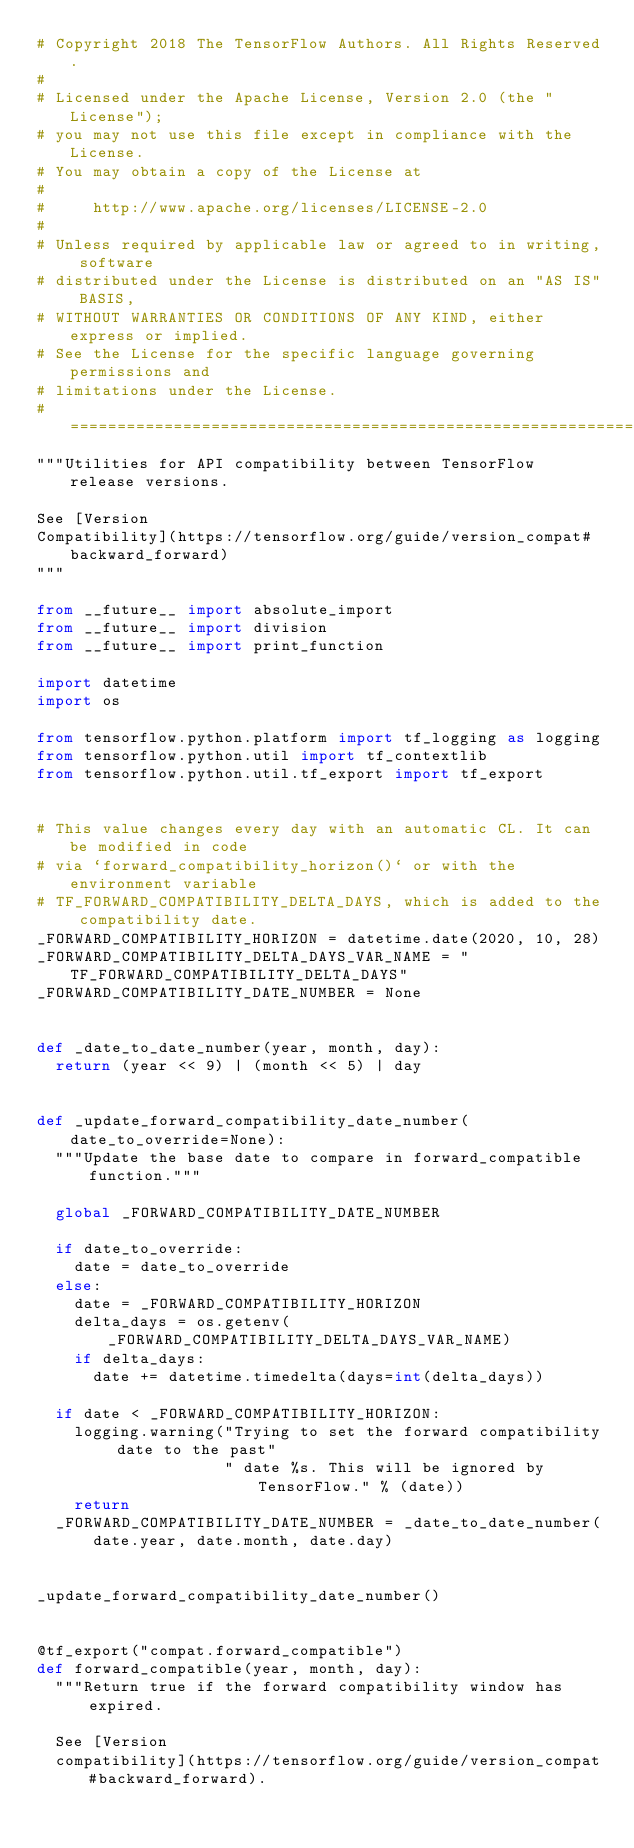<code> <loc_0><loc_0><loc_500><loc_500><_Python_># Copyright 2018 The TensorFlow Authors. All Rights Reserved.
#
# Licensed under the Apache License, Version 2.0 (the "License");
# you may not use this file except in compliance with the License.
# You may obtain a copy of the License at
#
#     http://www.apache.org/licenses/LICENSE-2.0
#
# Unless required by applicable law or agreed to in writing, software
# distributed under the License is distributed on an "AS IS" BASIS,
# WITHOUT WARRANTIES OR CONDITIONS OF ANY KIND, either express or implied.
# See the License for the specific language governing permissions and
# limitations under the License.
# ==============================================================================
"""Utilities for API compatibility between TensorFlow release versions.

See [Version
Compatibility](https://tensorflow.org/guide/version_compat#backward_forward)
"""

from __future__ import absolute_import
from __future__ import division
from __future__ import print_function

import datetime
import os

from tensorflow.python.platform import tf_logging as logging
from tensorflow.python.util import tf_contextlib
from tensorflow.python.util.tf_export import tf_export


# This value changes every day with an automatic CL. It can be modified in code
# via `forward_compatibility_horizon()` or with the environment variable
# TF_FORWARD_COMPATIBILITY_DELTA_DAYS, which is added to the compatibility date.
_FORWARD_COMPATIBILITY_HORIZON = datetime.date(2020, 10, 28)
_FORWARD_COMPATIBILITY_DELTA_DAYS_VAR_NAME = "TF_FORWARD_COMPATIBILITY_DELTA_DAYS"
_FORWARD_COMPATIBILITY_DATE_NUMBER = None


def _date_to_date_number(year, month, day):
  return (year << 9) | (month << 5) | day


def _update_forward_compatibility_date_number(date_to_override=None):
  """Update the base date to compare in forward_compatible function."""

  global _FORWARD_COMPATIBILITY_DATE_NUMBER

  if date_to_override:
    date = date_to_override
  else:
    date = _FORWARD_COMPATIBILITY_HORIZON
    delta_days = os.getenv(_FORWARD_COMPATIBILITY_DELTA_DAYS_VAR_NAME)
    if delta_days:
      date += datetime.timedelta(days=int(delta_days))

  if date < _FORWARD_COMPATIBILITY_HORIZON:
    logging.warning("Trying to set the forward compatibility date to the past"
                    " date %s. This will be ignored by TensorFlow." % (date))
    return
  _FORWARD_COMPATIBILITY_DATE_NUMBER = _date_to_date_number(
      date.year, date.month, date.day)


_update_forward_compatibility_date_number()


@tf_export("compat.forward_compatible")
def forward_compatible(year, month, day):
  """Return true if the forward compatibility window has expired.

  See [Version
  compatibility](https://tensorflow.org/guide/version_compat#backward_forward).
</code> 